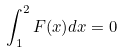Convert formula to latex. <formula><loc_0><loc_0><loc_500><loc_500>\int _ { 1 } ^ { 2 } F ( x ) d x = 0</formula> 